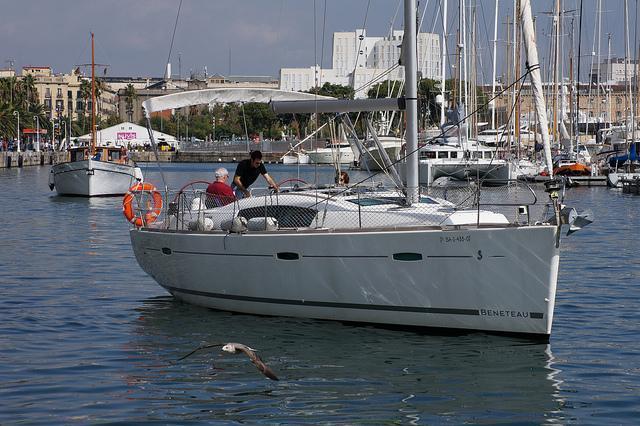Who is most likely to be the boat driver?
Select the correct answer and articulate reasoning with the following format: 'Answer: answer
Rationale: rationale.'
Options: Young man, boy, woman, old man. Answer: young man.
Rationale: The young man since he is standing by the steering wheel. 